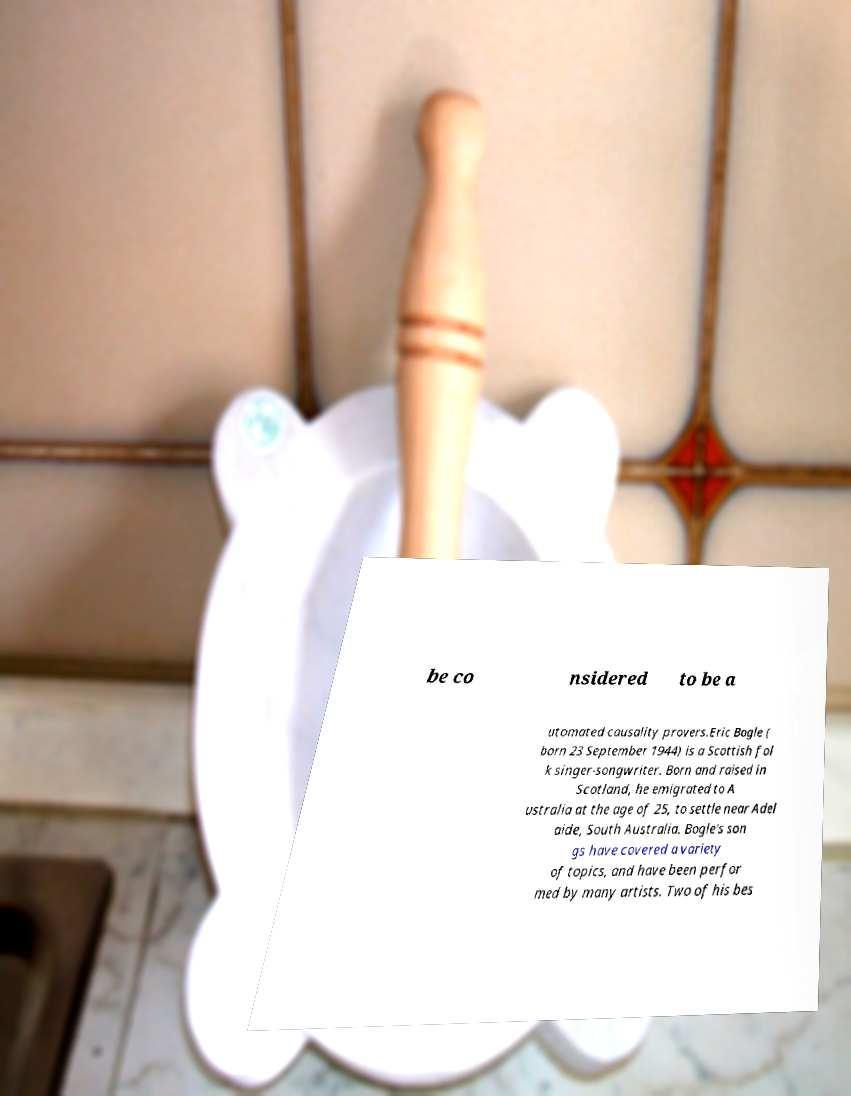Could you assist in decoding the text presented in this image and type it out clearly? be co nsidered to be a utomated causality provers.Eric Bogle ( born 23 September 1944) is a Scottish fol k singer-songwriter. Born and raised in Scotland, he emigrated to A ustralia at the age of 25, to settle near Adel aide, South Australia. Bogle's son gs have covered a variety of topics, and have been perfor med by many artists. Two of his bes 